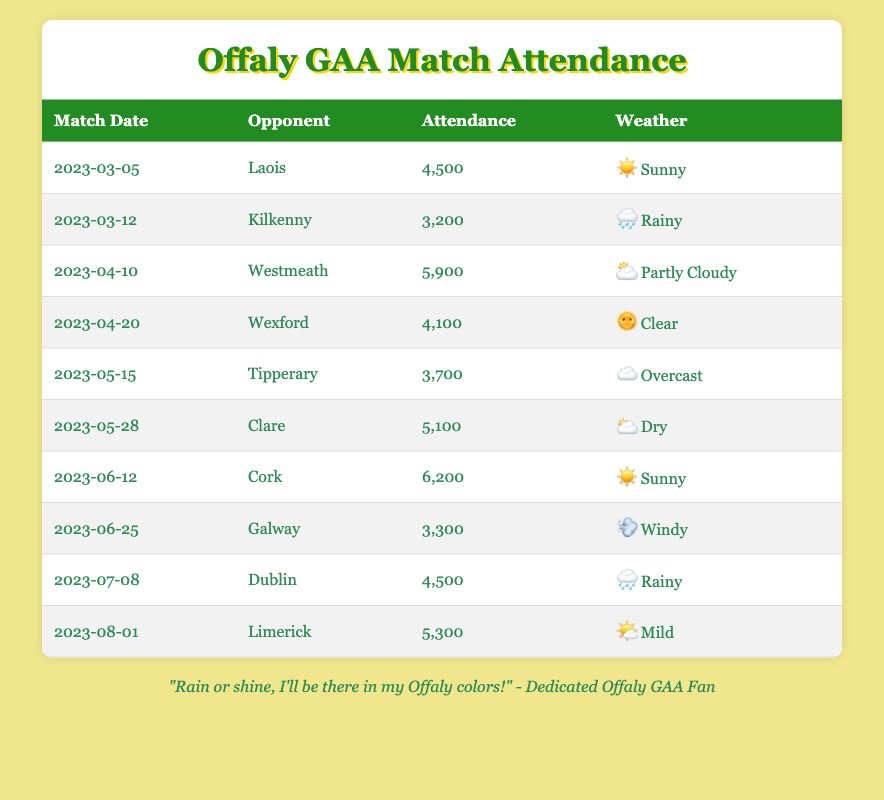What is the attendance for the match against Laois on March 5, 2023? The table lists the match date and corresponding attendance for each opponent. The row for Laois on March 5, 2023 shows an attendance of 4,500.
Answer: 4,500 How many matches were played under rainy weather conditions? By examining the weather condition column, the matches against Kilkenny on March 12 and Dublin on July 8 are listed as rainy, totaling 2 matches.
Answer: 2 What was the highest attendance recorded during the matches? By scanning through the attendance column of the table, the highest attendance is found in the row for Cork on June 12, 2023, which is 6,200.
Answer: 6,200 What is the total attendance for all matches played in June? The matches in June are against Cork (6,200) and Galway (3,300). Adding these two attendances yields 6,200 + 3,300 = 9,500.
Answer: 9,500 Did Offaly play against Wexford in clear weather conditions? The table indicates that the match against Wexford on April 20, 2023 is categorized as clear weather. Thus, the statement is true.
Answer: Yes What is the average attendance for matches that had sunny weather? The matches played in sunny weather are against Laois (4,500) and Cork (6,200). Summing the attendances gives 4,500 + 6,200 = 10,700. Dividing by the number of matches (2) results in an average of 10,700 / 2 = 5,350.
Answer: 5,350 Which match had the lowest attendance and what was that attendance? By reviewing the attendance column, it becomes clear that the match against Kilkenny on March 12, 2023 had the lowest attendance of 3,200.
Answer: 3,200 Is it true that all matches played in May had an attendance of more than 3,500? Analyzing the May matches: Tipperary (3,700) and Clare (5,100). Since both values exceed 3,500, the statement is true.
Answer: Yes How many matches had an attendance of 4,500 or more? By counting the matches with attendance of 4,500 or more: Laois (4,500), Westmeath (5,900), Cork (6,200), Clare (5,100), and Limerick (5,300), there are 5 matches that meet this criterion.
Answer: 5 